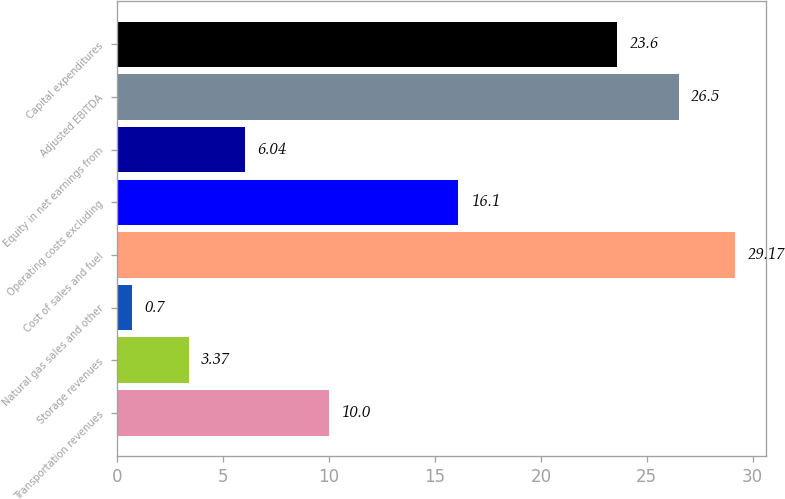<chart> <loc_0><loc_0><loc_500><loc_500><bar_chart><fcel>Transportation revenues<fcel>Storage revenues<fcel>Natural gas sales and other<fcel>Cost of sales and fuel<fcel>Operating costs excluding<fcel>Equity in net earnings from<fcel>Adjusted EBITDA<fcel>Capital expenditures<nl><fcel>10<fcel>3.37<fcel>0.7<fcel>29.17<fcel>16.1<fcel>6.04<fcel>26.5<fcel>23.6<nl></chart> 